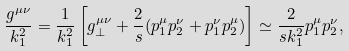<formula> <loc_0><loc_0><loc_500><loc_500>\frac { g ^ { \mu \nu } } { k _ { 1 } ^ { 2 } } = \frac { 1 } { k _ { 1 } ^ { 2 } } \left [ g ^ { \mu \nu } _ { \bot } + \frac { 2 } { s } ( p _ { 1 } ^ { \mu } p _ { 2 } ^ { \nu } + p _ { 1 } ^ { \nu } p _ { 2 } ^ { \mu } ) \right ] \simeq \frac { 2 } { s k _ { 1 } ^ { 2 } } p _ { 1 } ^ { \mu } p _ { 2 } ^ { \nu } ,</formula> 